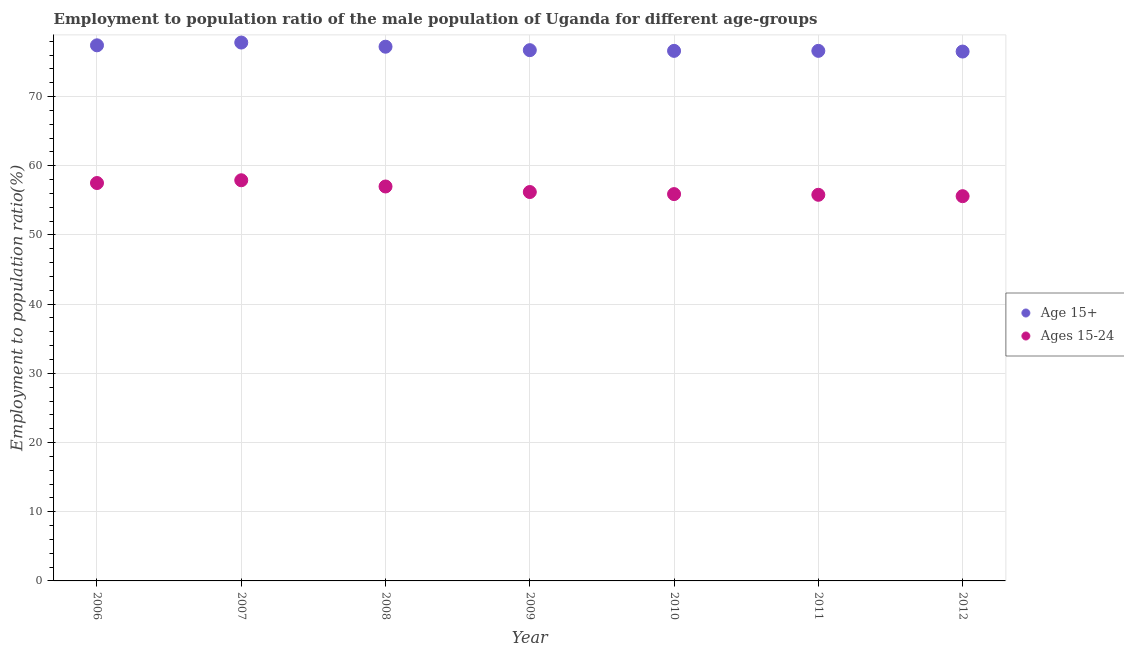Is the number of dotlines equal to the number of legend labels?
Give a very brief answer. Yes. What is the employment to population ratio(age 15+) in 2006?
Make the answer very short. 77.4. Across all years, what is the maximum employment to population ratio(age 15-24)?
Give a very brief answer. 57.9. Across all years, what is the minimum employment to population ratio(age 15-24)?
Offer a terse response. 55.6. In which year was the employment to population ratio(age 15+) maximum?
Your answer should be compact. 2007. What is the total employment to population ratio(age 15-24) in the graph?
Make the answer very short. 395.9. What is the difference between the employment to population ratio(age 15+) in 2007 and that in 2008?
Make the answer very short. 0.6. What is the difference between the employment to population ratio(age 15-24) in 2010 and the employment to population ratio(age 15+) in 2006?
Your response must be concise. -21.5. What is the average employment to population ratio(age 15-24) per year?
Your response must be concise. 56.56. In the year 2007, what is the difference between the employment to population ratio(age 15-24) and employment to population ratio(age 15+)?
Offer a terse response. -19.9. What is the ratio of the employment to population ratio(age 15+) in 2008 to that in 2011?
Ensure brevity in your answer.  1.01. Is the difference between the employment to population ratio(age 15-24) in 2011 and 2012 greater than the difference between the employment to population ratio(age 15+) in 2011 and 2012?
Keep it short and to the point. Yes. What is the difference between the highest and the second highest employment to population ratio(age 15+)?
Your answer should be very brief. 0.4. What is the difference between the highest and the lowest employment to population ratio(age 15-24)?
Provide a short and direct response. 2.3. In how many years, is the employment to population ratio(age 15+) greater than the average employment to population ratio(age 15+) taken over all years?
Provide a short and direct response. 3. Does the employment to population ratio(age 15+) monotonically increase over the years?
Your answer should be compact. No. Is the employment to population ratio(age 15+) strictly greater than the employment to population ratio(age 15-24) over the years?
Your response must be concise. Yes. How many years are there in the graph?
Give a very brief answer. 7. Are the values on the major ticks of Y-axis written in scientific E-notation?
Keep it short and to the point. No. Does the graph contain any zero values?
Provide a succinct answer. No. Does the graph contain grids?
Keep it short and to the point. Yes. Where does the legend appear in the graph?
Offer a very short reply. Center right. How are the legend labels stacked?
Provide a short and direct response. Vertical. What is the title of the graph?
Your answer should be very brief. Employment to population ratio of the male population of Uganda for different age-groups. Does "Domestic liabilities" appear as one of the legend labels in the graph?
Give a very brief answer. No. What is the label or title of the X-axis?
Your answer should be very brief. Year. What is the label or title of the Y-axis?
Your answer should be compact. Employment to population ratio(%). What is the Employment to population ratio(%) of Age 15+ in 2006?
Ensure brevity in your answer.  77.4. What is the Employment to population ratio(%) of Ages 15-24 in 2006?
Offer a very short reply. 57.5. What is the Employment to population ratio(%) of Age 15+ in 2007?
Give a very brief answer. 77.8. What is the Employment to population ratio(%) in Ages 15-24 in 2007?
Offer a terse response. 57.9. What is the Employment to population ratio(%) in Age 15+ in 2008?
Your response must be concise. 77.2. What is the Employment to population ratio(%) of Age 15+ in 2009?
Provide a short and direct response. 76.7. What is the Employment to population ratio(%) in Ages 15-24 in 2009?
Your answer should be very brief. 56.2. What is the Employment to population ratio(%) in Age 15+ in 2010?
Your answer should be very brief. 76.6. What is the Employment to population ratio(%) of Ages 15-24 in 2010?
Give a very brief answer. 55.9. What is the Employment to population ratio(%) in Age 15+ in 2011?
Your answer should be very brief. 76.6. What is the Employment to population ratio(%) of Ages 15-24 in 2011?
Provide a short and direct response. 55.8. What is the Employment to population ratio(%) in Age 15+ in 2012?
Keep it short and to the point. 76.5. What is the Employment to population ratio(%) of Ages 15-24 in 2012?
Offer a terse response. 55.6. Across all years, what is the maximum Employment to population ratio(%) of Age 15+?
Offer a terse response. 77.8. Across all years, what is the maximum Employment to population ratio(%) in Ages 15-24?
Provide a short and direct response. 57.9. Across all years, what is the minimum Employment to population ratio(%) of Age 15+?
Keep it short and to the point. 76.5. Across all years, what is the minimum Employment to population ratio(%) of Ages 15-24?
Make the answer very short. 55.6. What is the total Employment to population ratio(%) of Age 15+ in the graph?
Offer a terse response. 538.8. What is the total Employment to population ratio(%) of Ages 15-24 in the graph?
Your answer should be very brief. 395.9. What is the difference between the Employment to population ratio(%) of Age 15+ in 2006 and that in 2009?
Offer a terse response. 0.7. What is the difference between the Employment to population ratio(%) in Ages 15-24 in 2006 and that in 2010?
Offer a terse response. 1.6. What is the difference between the Employment to population ratio(%) in Age 15+ in 2006 and that in 2012?
Offer a very short reply. 0.9. What is the difference between the Employment to population ratio(%) of Ages 15-24 in 2006 and that in 2012?
Make the answer very short. 1.9. What is the difference between the Employment to population ratio(%) in Age 15+ in 2007 and that in 2008?
Offer a terse response. 0.6. What is the difference between the Employment to population ratio(%) of Age 15+ in 2007 and that in 2009?
Your answer should be compact. 1.1. What is the difference between the Employment to population ratio(%) in Ages 15-24 in 2007 and that in 2010?
Your answer should be very brief. 2. What is the difference between the Employment to population ratio(%) of Ages 15-24 in 2007 and that in 2011?
Your answer should be compact. 2.1. What is the difference between the Employment to population ratio(%) of Ages 15-24 in 2007 and that in 2012?
Your response must be concise. 2.3. What is the difference between the Employment to population ratio(%) in Ages 15-24 in 2008 and that in 2010?
Make the answer very short. 1.1. What is the difference between the Employment to population ratio(%) in Ages 15-24 in 2008 and that in 2011?
Your response must be concise. 1.2. What is the difference between the Employment to population ratio(%) of Ages 15-24 in 2008 and that in 2012?
Provide a succinct answer. 1.4. What is the difference between the Employment to population ratio(%) in Age 15+ in 2009 and that in 2010?
Your response must be concise. 0.1. What is the difference between the Employment to population ratio(%) in Ages 15-24 in 2009 and that in 2010?
Give a very brief answer. 0.3. What is the difference between the Employment to population ratio(%) of Age 15+ in 2009 and that in 2011?
Your answer should be very brief. 0.1. What is the difference between the Employment to population ratio(%) in Ages 15-24 in 2009 and that in 2011?
Make the answer very short. 0.4. What is the difference between the Employment to population ratio(%) of Age 15+ in 2009 and that in 2012?
Provide a succinct answer. 0.2. What is the difference between the Employment to population ratio(%) of Ages 15-24 in 2009 and that in 2012?
Ensure brevity in your answer.  0.6. What is the difference between the Employment to population ratio(%) in Age 15+ in 2010 and that in 2011?
Make the answer very short. 0. What is the difference between the Employment to population ratio(%) in Ages 15-24 in 2010 and that in 2011?
Offer a very short reply. 0.1. What is the difference between the Employment to population ratio(%) in Ages 15-24 in 2011 and that in 2012?
Your answer should be compact. 0.2. What is the difference between the Employment to population ratio(%) of Age 15+ in 2006 and the Employment to population ratio(%) of Ages 15-24 in 2008?
Your answer should be very brief. 20.4. What is the difference between the Employment to population ratio(%) of Age 15+ in 2006 and the Employment to population ratio(%) of Ages 15-24 in 2009?
Offer a terse response. 21.2. What is the difference between the Employment to population ratio(%) in Age 15+ in 2006 and the Employment to population ratio(%) in Ages 15-24 in 2010?
Your answer should be compact. 21.5. What is the difference between the Employment to population ratio(%) of Age 15+ in 2006 and the Employment to population ratio(%) of Ages 15-24 in 2011?
Ensure brevity in your answer.  21.6. What is the difference between the Employment to population ratio(%) of Age 15+ in 2006 and the Employment to population ratio(%) of Ages 15-24 in 2012?
Your answer should be very brief. 21.8. What is the difference between the Employment to population ratio(%) in Age 15+ in 2007 and the Employment to population ratio(%) in Ages 15-24 in 2008?
Keep it short and to the point. 20.8. What is the difference between the Employment to population ratio(%) in Age 15+ in 2007 and the Employment to population ratio(%) in Ages 15-24 in 2009?
Provide a succinct answer. 21.6. What is the difference between the Employment to population ratio(%) of Age 15+ in 2007 and the Employment to population ratio(%) of Ages 15-24 in 2010?
Provide a succinct answer. 21.9. What is the difference between the Employment to population ratio(%) of Age 15+ in 2007 and the Employment to population ratio(%) of Ages 15-24 in 2011?
Your response must be concise. 22. What is the difference between the Employment to population ratio(%) in Age 15+ in 2007 and the Employment to population ratio(%) in Ages 15-24 in 2012?
Offer a terse response. 22.2. What is the difference between the Employment to population ratio(%) in Age 15+ in 2008 and the Employment to population ratio(%) in Ages 15-24 in 2010?
Make the answer very short. 21.3. What is the difference between the Employment to population ratio(%) in Age 15+ in 2008 and the Employment to population ratio(%) in Ages 15-24 in 2011?
Make the answer very short. 21.4. What is the difference between the Employment to population ratio(%) of Age 15+ in 2008 and the Employment to population ratio(%) of Ages 15-24 in 2012?
Offer a terse response. 21.6. What is the difference between the Employment to population ratio(%) of Age 15+ in 2009 and the Employment to population ratio(%) of Ages 15-24 in 2010?
Your answer should be very brief. 20.8. What is the difference between the Employment to population ratio(%) of Age 15+ in 2009 and the Employment to population ratio(%) of Ages 15-24 in 2011?
Keep it short and to the point. 20.9. What is the difference between the Employment to population ratio(%) in Age 15+ in 2009 and the Employment to population ratio(%) in Ages 15-24 in 2012?
Ensure brevity in your answer.  21.1. What is the difference between the Employment to population ratio(%) in Age 15+ in 2010 and the Employment to population ratio(%) in Ages 15-24 in 2011?
Give a very brief answer. 20.8. What is the difference between the Employment to population ratio(%) in Age 15+ in 2010 and the Employment to population ratio(%) in Ages 15-24 in 2012?
Make the answer very short. 21. What is the average Employment to population ratio(%) of Age 15+ per year?
Your response must be concise. 76.97. What is the average Employment to population ratio(%) of Ages 15-24 per year?
Offer a very short reply. 56.56. In the year 2006, what is the difference between the Employment to population ratio(%) of Age 15+ and Employment to population ratio(%) of Ages 15-24?
Your answer should be very brief. 19.9. In the year 2008, what is the difference between the Employment to population ratio(%) of Age 15+ and Employment to population ratio(%) of Ages 15-24?
Offer a very short reply. 20.2. In the year 2009, what is the difference between the Employment to population ratio(%) of Age 15+ and Employment to population ratio(%) of Ages 15-24?
Your answer should be compact. 20.5. In the year 2010, what is the difference between the Employment to population ratio(%) in Age 15+ and Employment to population ratio(%) in Ages 15-24?
Ensure brevity in your answer.  20.7. In the year 2011, what is the difference between the Employment to population ratio(%) of Age 15+ and Employment to population ratio(%) of Ages 15-24?
Make the answer very short. 20.8. In the year 2012, what is the difference between the Employment to population ratio(%) of Age 15+ and Employment to population ratio(%) of Ages 15-24?
Your answer should be compact. 20.9. What is the ratio of the Employment to population ratio(%) of Ages 15-24 in 2006 to that in 2007?
Offer a very short reply. 0.99. What is the ratio of the Employment to population ratio(%) in Ages 15-24 in 2006 to that in 2008?
Provide a short and direct response. 1.01. What is the ratio of the Employment to population ratio(%) in Age 15+ in 2006 to that in 2009?
Offer a terse response. 1.01. What is the ratio of the Employment to population ratio(%) in Ages 15-24 in 2006 to that in 2009?
Provide a succinct answer. 1.02. What is the ratio of the Employment to population ratio(%) of Age 15+ in 2006 to that in 2010?
Provide a short and direct response. 1.01. What is the ratio of the Employment to population ratio(%) of Ages 15-24 in 2006 to that in 2010?
Your answer should be compact. 1.03. What is the ratio of the Employment to population ratio(%) of Age 15+ in 2006 to that in 2011?
Offer a very short reply. 1.01. What is the ratio of the Employment to population ratio(%) in Ages 15-24 in 2006 to that in 2011?
Provide a succinct answer. 1.03. What is the ratio of the Employment to population ratio(%) of Age 15+ in 2006 to that in 2012?
Your answer should be compact. 1.01. What is the ratio of the Employment to population ratio(%) of Ages 15-24 in 2006 to that in 2012?
Give a very brief answer. 1.03. What is the ratio of the Employment to population ratio(%) in Ages 15-24 in 2007 to that in 2008?
Provide a short and direct response. 1.02. What is the ratio of the Employment to population ratio(%) of Age 15+ in 2007 to that in 2009?
Ensure brevity in your answer.  1.01. What is the ratio of the Employment to population ratio(%) of Ages 15-24 in 2007 to that in 2009?
Provide a short and direct response. 1.03. What is the ratio of the Employment to population ratio(%) of Age 15+ in 2007 to that in 2010?
Your response must be concise. 1.02. What is the ratio of the Employment to population ratio(%) of Ages 15-24 in 2007 to that in 2010?
Give a very brief answer. 1.04. What is the ratio of the Employment to population ratio(%) in Age 15+ in 2007 to that in 2011?
Offer a terse response. 1.02. What is the ratio of the Employment to population ratio(%) in Ages 15-24 in 2007 to that in 2011?
Your answer should be compact. 1.04. What is the ratio of the Employment to population ratio(%) in Ages 15-24 in 2007 to that in 2012?
Provide a short and direct response. 1.04. What is the ratio of the Employment to population ratio(%) in Age 15+ in 2008 to that in 2009?
Your answer should be very brief. 1.01. What is the ratio of the Employment to population ratio(%) in Ages 15-24 in 2008 to that in 2009?
Keep it short and to the point. 1.01. What is the ratio of the Employment to population ratio(%) in Age 15+ in 2008 to that in 2010?
Your answer should be very brief. 1.01. What is the ratio of the Employment to population ratio(%) of Ages 15-24 in 2008 to that in 2010?
Provide a succinct answer. 1.02. What is the ratio of the Employment to population ratio(%) in Age 15+ in 2008 to that in 2011?
Keep it short and to the point. 1.01. What is the ratio of the Employment to population ratio(%) in Ages 15-24 in 2008 to that in 2011?
Your answer should be very brief. 1.02. What is the ratio of the Employment to population ratio(%) of Age 15+ in 2008 to that in 2012?
Ensure brevity in your answer.  1.01. What is the ratio of the Employment to population ratio(%) of Ages 15-24 in 2008 to that in 2012?
Keep it short and to the point. 1.03. What is the ratio of the Employment to population ratio(%) of Ages 15-24 in 2009 to that in 2010?
Give a very brief answer. 1.01. What is the ratio of the Employment to population ratio(%) in Ages 15-24 in 2009 to that in 2012?
Make the answer very short. 1.01. What is the ratio of the Employment to population ratio(%) of Ages 15-24 in 2010 to that in 2011?
Make the answer very short. 1. What is the ratio of the Employment to population ratio(%) in Ages 15-24 in 2010 to that in 2012?
Make the answer very short. 1.01. What is the ratio of the Employment to population ratio(%) in Age 15+ in 2011 to that in 2012?
Your response must be concise. 1. What is the ratio of the Employment to population ratio(%) in Ages 15-24 in 2011 to that in 2012?
Ensure brevity in your answer.  1. What is the difference between the highest and the second highest Employment to population ratio(%) in Age 15+?
Give a very brief answer. 0.4. What is the difference between the highest and the second highest Employment to population ratio(%) of Ages 15-24?
Your answer should be compact. 0.4. What is the difference between the highest and the lowest Employment to population ratio(%) of Age 15+?
Ensure brevity in your answer.  1.3. What is the difference between the highest and the lowest Employment to population ratio(%) in Ages 15-24?
Provide a succinct answer. 2.3. 